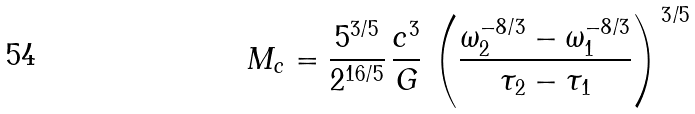<formula> <loc_0><loc_0><loc_500><loc_500>M _ { c } = \frac { 5 ^ { 3 / 5 } } { 2 ^ { 1 6 / 5 } } \, \frac { c ^ { 3 } } { G } \, \left ( \frac { \omega _ { 2 } ^ { - 8 / 3 } - \omega _ { 1 } ^ { - 8 / 3 } } { \tau _ { 2 } - \tau _ { 1 } } \right ) ^ { \, 3 / 5 }</formula> 